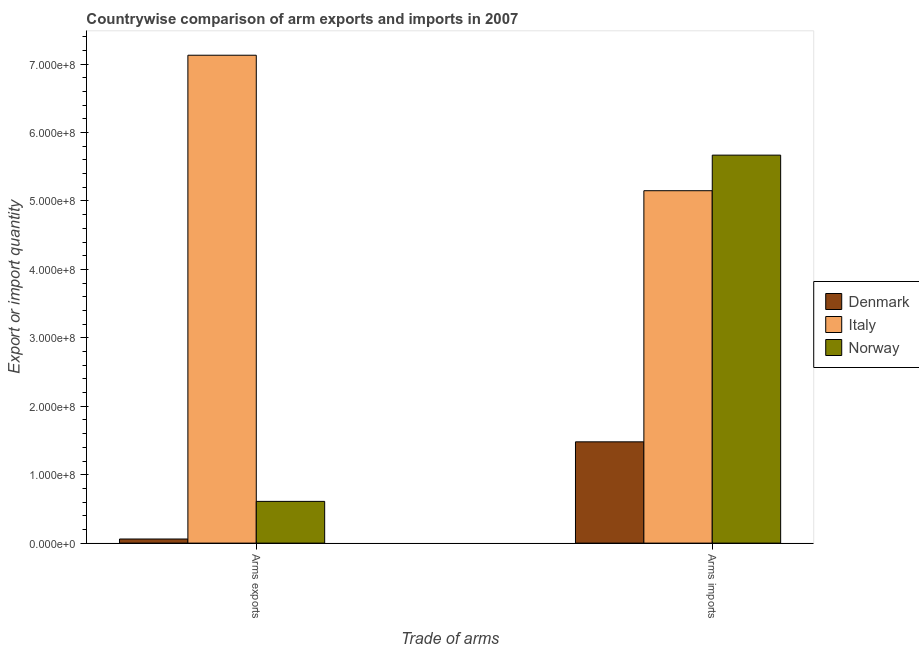How many different coloured bars are there?
Your response must be concise. 3. How many groups of bars are there?
Offer a terse response. 2. Are the number of bars per tick equal to the number of legend labels?
Your answer should be very brief. Yes. Are the number of bars on each tick of the X-axis equal?
Offer a terse response. Yes. How many bars are there on the 2nd tick from the right?
Give a very brief answer. 3. What is the label of the 1st group of bars from the left?
Give a very brief answer. Arms exports. What is the arms imports in Norway?
Your answer should be compact. 5.67e+08. Across all countries, what is the maximum arms imports?
Offer a very short reply. 5.67e+08. Across all countries, what is the minimum arms imports?
Your answer should be compact. 1.48e+08. In which country was the arms imports minimum?
Your answer should be very brief. Denmark. What is the total arms imports in the graph?
Your response must be concise. 1.23e+09. What is the difference between the arms exports in Norway and that in Italy?
Provide a succinct answer. -6.52e+08. What is the difference between the arms exports in Italy and the arms imports in Denmark?
Offer a terse response. 5.65e+08. What is the average arms exports per country?
Give a very brief answer. 2.60e+08. What is the difference between the arms imports and arms exports in Denmark?
Your answer should be compact. 1.42e+08. What is the ratio of the arms imports in Denmark to that in Italy?
Ensure brevity in your answer.  0.29. In how many countries, is the arms exports greater than the average arms exports taken over all countries?
Your answer should be compact. 1. What does the 1st bar from the left in Arms imports represents?
Make the answer very short. Denmark. What does the 2nd bar from the right in Arms exports represents?
Make the answer very short. Italy. Are all the bars in the graph horizontal?
Your response must be concise. No. How many countries are there in the graph?
Your response must be concise. 3. What is the difference between two consecutive major ticks on the Y-axis?
Provide a short and direct response. 1.00e+08. Are the values on the major ticks of Y-axis written in scientific E-notation?
Your response must be concise. Yes. How many legend labels are there?
Your answer should be compact. 3. How are the legend labels stacked?
Give a very brief answer. Vertical. What is the title of the graph?
Provide a succinct answer. Countrywise comparison of arm exports and imports in 2007. Does "Spain" appear as one of the legend labels in the graph?
Your answer should be compact. No. What is the label or title of the X-axis?
Your answer should be compact. Trade of arms. What is the label or title of the Y-axis?
Provide a short and direct response. Export or import quantity. What is the Export or import quantity in Italy in Arms exports?
Ensure brevity in your answer.  7.13e+08. What is the Export or import quantity of Norway in Arms exports?
Make the answer very short. 6.10e+07. What is the Export or import quantity of Denmark in Arms imports?
Your answer should be very brief. 1.48e+08. What is the Export or import quantity in Italy in Arms imports?
Give a very brief answer. 5.15e+08. What is the Export or import quantity of Norway in Arms imports?
Keep it short and to the point. 5.67e+08. Across all Trade of arms, what is the maximum Export or import quantity in Denmark?
Ensure brevity in your answer.  1.48e+08. Across all Trade of arms, what is the maximum Export or import quantity in Italy?
Make the answer very short. 7.13e+08. Across all Trade of arms, what is the maximum Export or import quantity in Norway?
Your response must be concise. 5.67e+08. Across all Trade of arms, what is the minimum Export or import quantity in Denmark?
Ensure brevity in your answer.  6.00e+06. Across all Trade of arms, what is the minimum Export or import quantity of Italy?
Ensure brevity in your answer.  5.15e+08. Across all Trade of arms, what is the minimum Export or import quantity of Norway?
Your answer should be compact. 6.10e+07. What is the total Export or import quantity in Denmark in the graph?
Your response must be concise. 1.54e+08. What is the total Export or import quantity in Italy in the graph?
Make the answer very short. 1.23e+09. What is the total Export or import quantity of Norway in the graph?
Offer a terse response. 6.28e+08. What is the difference between the Export or import quantity of Denmark in Arms exports and that in Arms imports?
Your response must be concise. -1.42e+08. What is the difference between the Export or import quantity of Italy in Arms exports and that in Arms imports?
Provide a succinct answer. 1.98e+08. What is the difference between the Export or import quantity in Norway in Arms exports and that in Arms imports?
Offer a terse response. -5.06e+08. What is the difference between the Export or import quantity in Denmark in Arms exports and the Export or import quantity in Italy in Arms imports?
Your response must be concise. -5.09e+08. What is the difference between the Export or import quantity in Denmark in Arms exports and the Export or import quantity in Norway in Arms imports?
Your response must be concise. -5.61e+08. What is the difference between the Export or import quantity of Italy in Arms exports and the Export or import quantity of Norway in Arms imports?
Your response must be concise. 1.46e+08. What is the average Export or import quantity of Denmark per Trade of arms?
Your response must be concise. 7.70e+07. What is the average Export or import quantity of Italy per Trade of arms?
Your answer should be compact. 6.14e+08. What is the average Export or import quantity in Norway per Trade of arms?
Make the answer very short. 3.14e+08. What is the difference between the Export or import quantity in Denmark and Export or import quantity in Italy in Arms exports?
Your answer should be compact. -7.07e+08. What is the difference between the Export or import quantity of Denmark and Export or import quantity of Norway in Arms exports?
Keep it short and to the point. -5.50e+07. What is the difference between the Export or import quantity of Italy and Export or import quantity of Norway in Arms exports?
Provide a short and direct response. 6.52e+08. What is the difference between the Export or import quantity in Denmark and Export or import quantity in Italy in Arms imports?
Your response must be concise. -3.67e+08. What is the difference between the Export or import quantity in Denmark and Export or import quantity in Norway in Arms imports?
Keep it short and to the point. -4.19e+08. What is the difference between the Export or import quantity in Italy and Export or import quantity in Norway in Arms imports?
Make the answer very short. -5.20e+07. What is the ratio of the Export or import quantity of Denmark in Arms exports to that in Arms imports?
Keep it short and to the point. 0.04. What is the ratio of the Export or import quantity in Italy in Arms exports to that in Arms imports?
Make the answer very short. 1.38. What is the ratio of the Export or import quantity in Norway in Arms exports to that in Arms imports?
Your response must be concise. 0.11. What is the difference between the highest and the second highest Export or import quantity in Denmark?
Provide a succinct answer. 1.42e+08. What is the difference between the highest and the second highest Export or import quantity in Italy?
Give a very brief answer. 1.98e+08. What is the difference between the highest and the second highest Export or import quantity of Norway?
Your answer should be very brief. 5.06e+08. What is the difference between the highest and the lowest Export or import quantity of Denmark?
Your answer should be very brief. 1.42e+08. What is the difference between the highest and the lowest Export or import quantity of Italy?
Offer a very short reply. 1.98e+08. What is the difference between the highest and the lowest Export or import quantity in Norway?
Your response must be concise. 5.06e+08. 